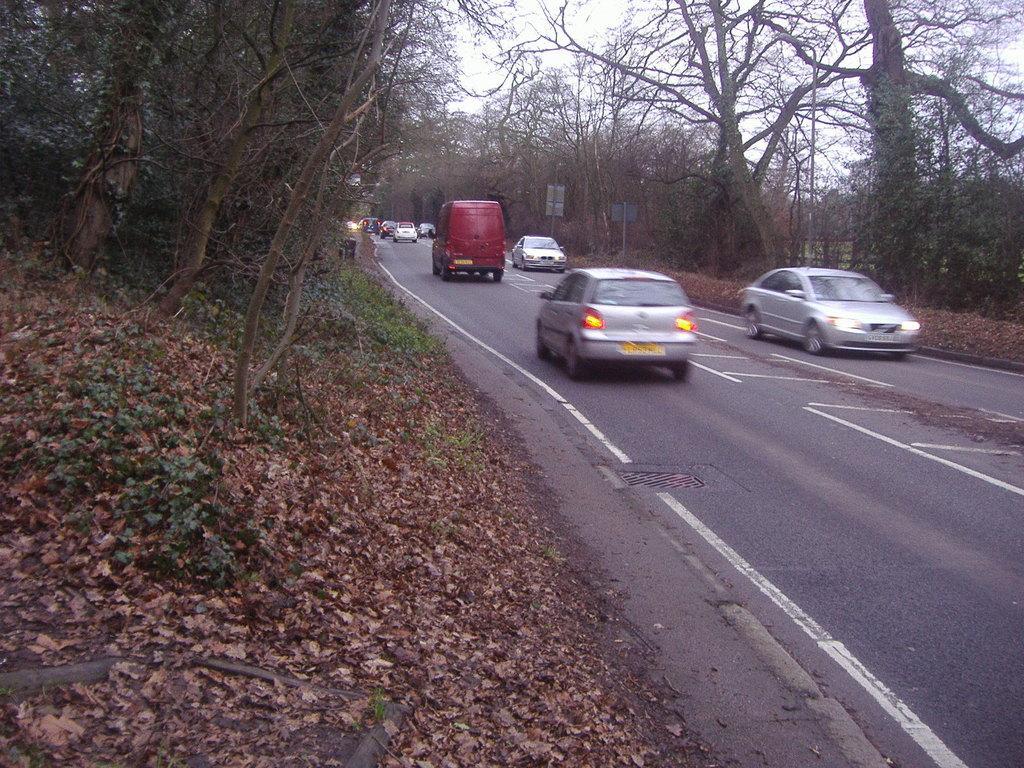Describe this image in one or two sentences. In this image I see the road on which there are vehicles and I see the trees and the plants. In the background I see the sky and I see 2 boards over here and I see the dried leaves. 